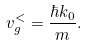<formula> <loc_0><loc_0><loc_500><loc_500>v _ { g } ^ { < } = \frac { \hbar { k } _ { 0 } } { m } .</formula> 